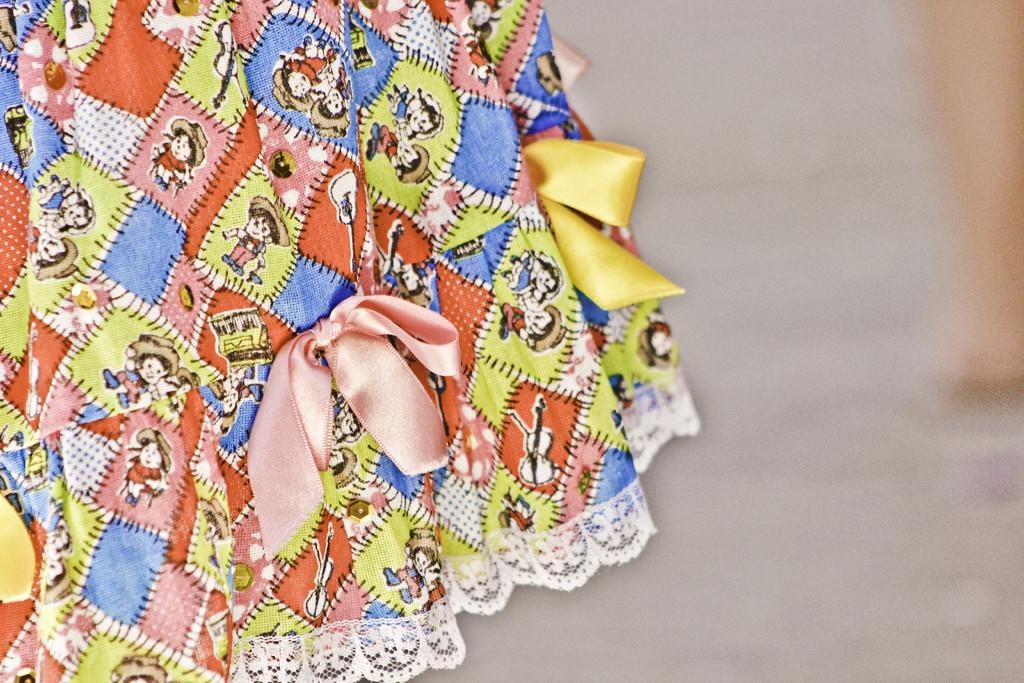What type of material is featured in the image? There is dress material in the image. Can you describe the design of the dress material? The dress material has multi-color patterns. What additional detail can be observed on the dress material? There are cartoon images on the dress material. How many tomatoes are visible on the dress material in the image? There are no tomatoes present on the dress material in the image; it features cartoon images instead. 